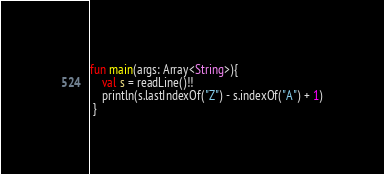<code> <loc_0><loc_0><loc_500><loc_500><_Kotlin_>fun main(args: Array<String>){
    val s = readLine()!!
    println(s.lastIndexOf("Z") - s.indexOf("A") + 1)
 }</code> 